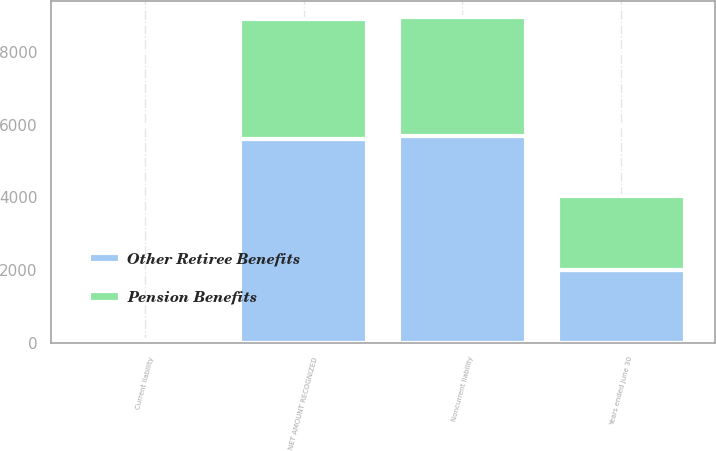Convert chart. <chart><loc_0><loc_0><loc_500><loc_500><stacked_bar_chart><ecel><fcel>Years ended June 30<fcel>Current liability<fcel>Noncurrent liability<fcel>NET AMOUNT RECOGNIZED<nl><fcel>Other Retiree Benefits<fcel>2012<fcel>43<fcel>5684<fcel>5599<nl><fcel>Pension Benefits<fcel>2012<fcel>23<fcel>3270<fcel>3293<nl></chart> 